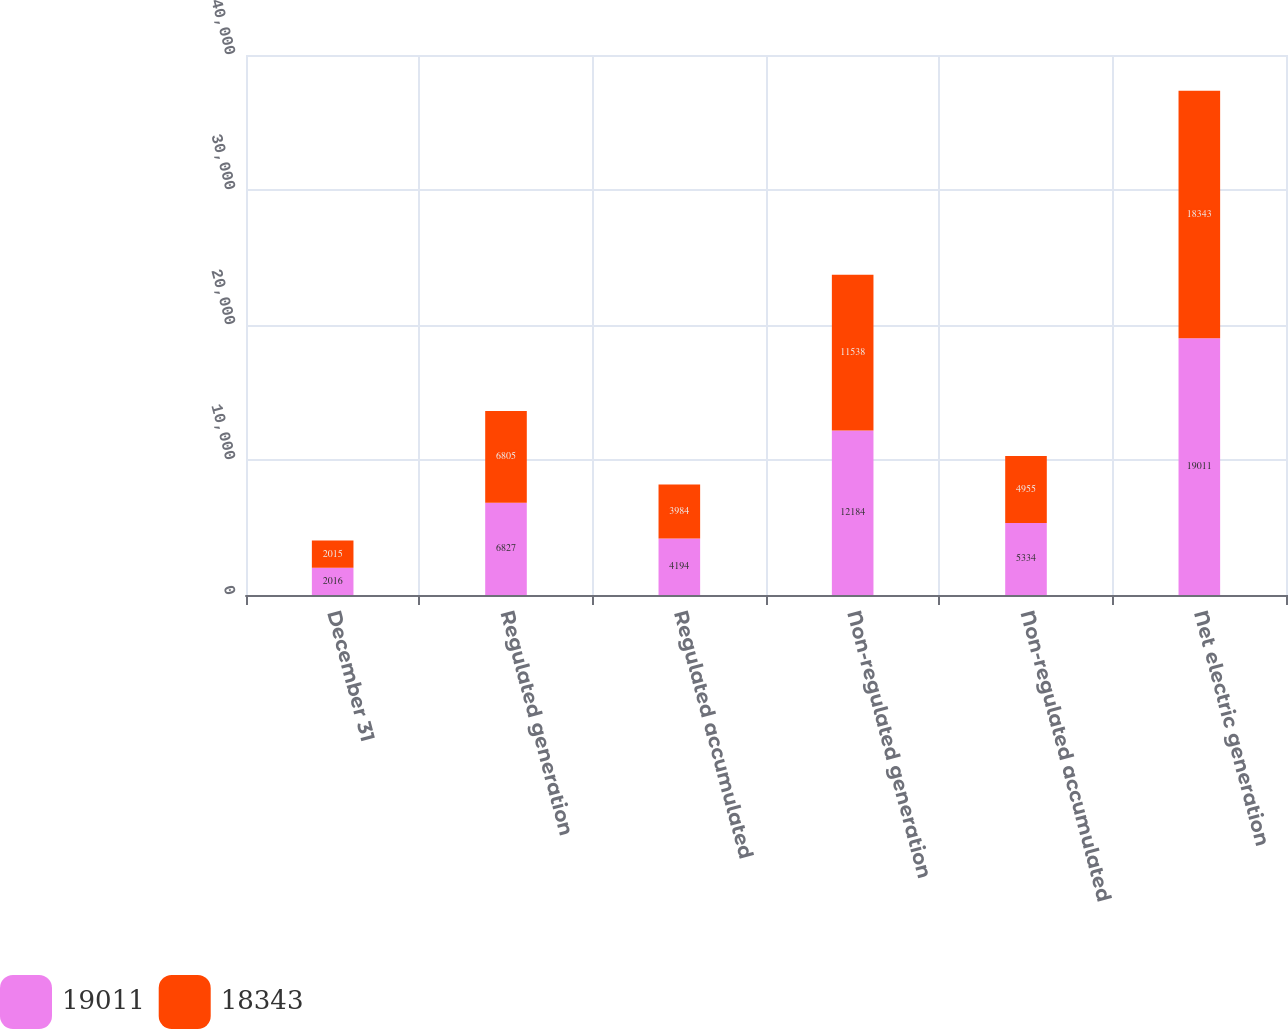Convert chart. <chart><loc_0><loc_0><loc_500><loc_500><stacked_bar_chart><ecel><fcel>December 31<fcel>Regulated generation<fcel>Regulated accumulated<fcel>Non-regulated generation<fcel>Non-regulated accumulated<fcel>Net electric generation<nl><fcel>19011<fcel>2016<fcel>6827<fcel>4194<fcel>12184<fcel>5334<fcel>19011<nl><fcel>18343<fcel>2015<fcel>6805<fcel>3984<fcel>11538<fcel>4955<fcel>18343<nl></chart> 